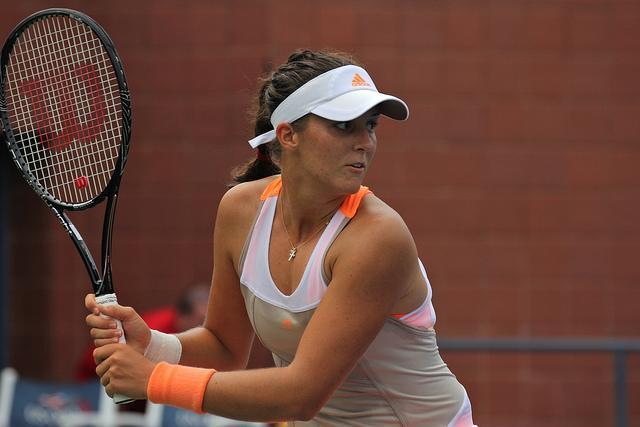How many people are visible?
Give a very brief answer. 1. 